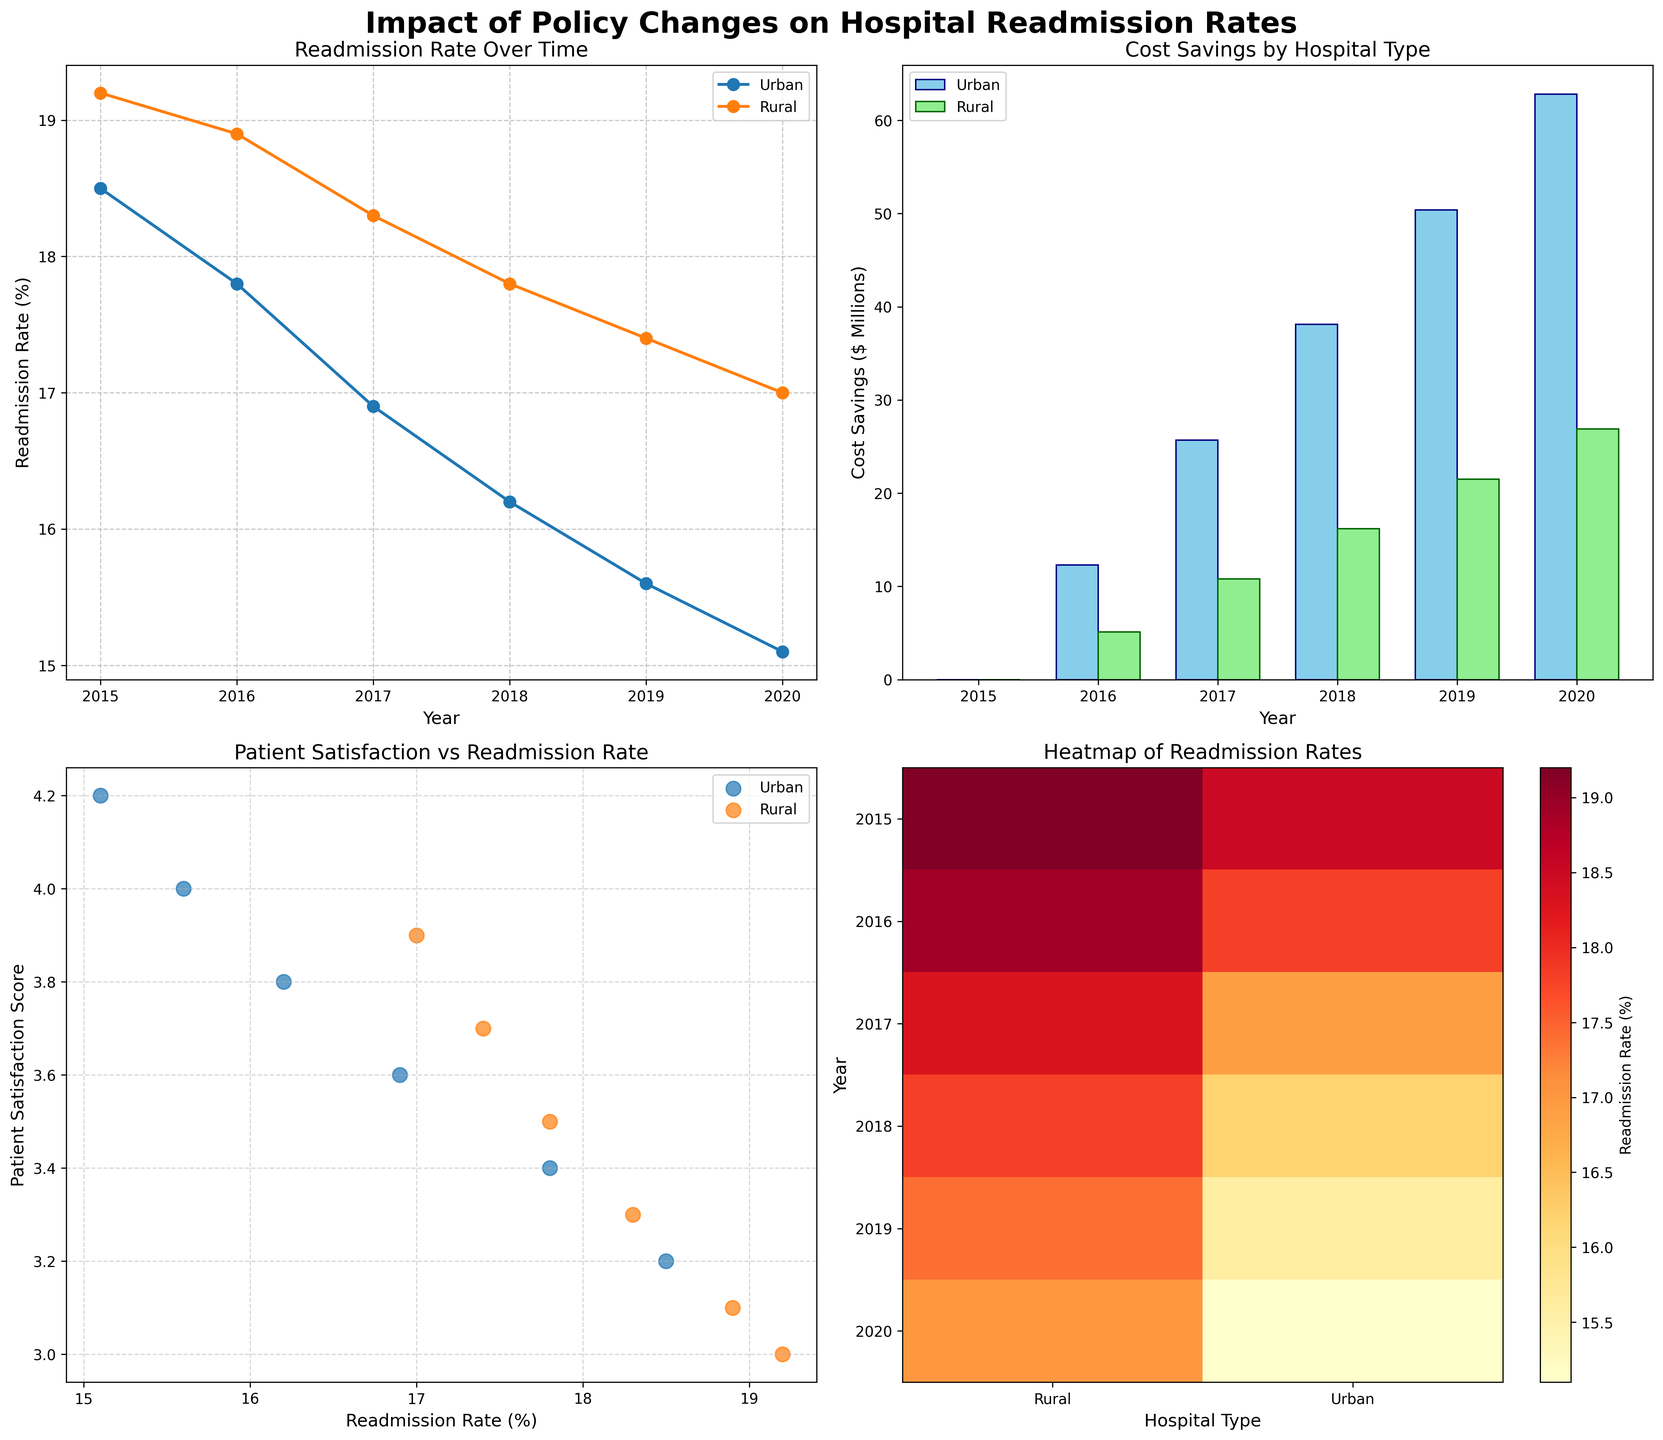What is the overall trend of readmission rates from 2015 to 2020 in urban hospitals? The line plot in the first subplot shows a consistent decrease in readmission rates for urban hospitals from 2015 to 2020. The markers for urban hospitals (blue line) drop from around 18.5% in 2015 to about 15.1% in 2020. This downward trend indicates an overall decline in readmission rates.
Answer: Downward trend Which year shows the highest cost savings for urban hospitals? In the second subplot, the bar plot for cost savings shows that the highest cost savings for urban hospitals (skyblue bars) occur in 2020, with approximately 62.8 million dollars saved.
Answer: 2020 What is the difference in readmission rates between urban and rural hospitals in 2020? The line plot in the first subplot indicates that in 2020, the readmission rate for urban hospitals is about 15.1%, whereas for rural hospitals, it is around 17.0%. The difference is calculated as 17.0% - 15.1% = 1.9%.
Answer: 1.9% How do patient satisfaction scores correlate with readmission rates for urban hospitals? In the third subplot, the scatter plot shows that as readmission rates decrease, patient satisfaction scores for urban hospitals (blue markers) increase. For example, a lower readmission rate (~15.1%) in 2020 correlates with a higher satisfaction score (4.2). This suggests a negative correlation.
Answer: Negative correlation Which policy change resulted in the largest reduction in readmission rates for rural hospitals? Referring to the peak-to-trough differences in the line plot's red line for rural hospitals, the largest reduction appears to occur between 2017 (HRRP Expansion) and 2018 (Value-Based Purchasing), where the readmission rate drops from about 18.3% to 17.8%. The reduction is 18.3% - 17.8% = 0.5%.
Answer: Value-Based Purchasing Are the cost savings in 2019 higher for urban or rural hospitals? In the second subplot's bar plot for 2019, the cost savings for urban hospitals is approximately 50.4 million dollars, whereas for rural hospitals, it is around 21.5 million dollars. Thus, urban hospitals have higher cost savings.
Answer: Urban hospitals Which hospital type has generally higher patient satisfaction scores over the years? Observing the scatter plot, we can see that urban hospitals (blue markers) generally have higher patient satisfaction scores than rural hospitals (red markers) in nearly all years. For instance, urban hospitals have a score of 4.2 in 2020 while rural hospitals score 3.9.
Answer: Urban hospitals What is the relationship between policy changes and patient satisfaction scores for rural hospitals? The scatter plot shows an upward trend in patient satisfaction scores for rural hospitals (red markers) from 2015 to 2020. Each successive policy change correlates with a higher satisfaction score, suggesting that policy changes positively impact patient satisfaction in rural hospitals.
Answer: Positive impact 